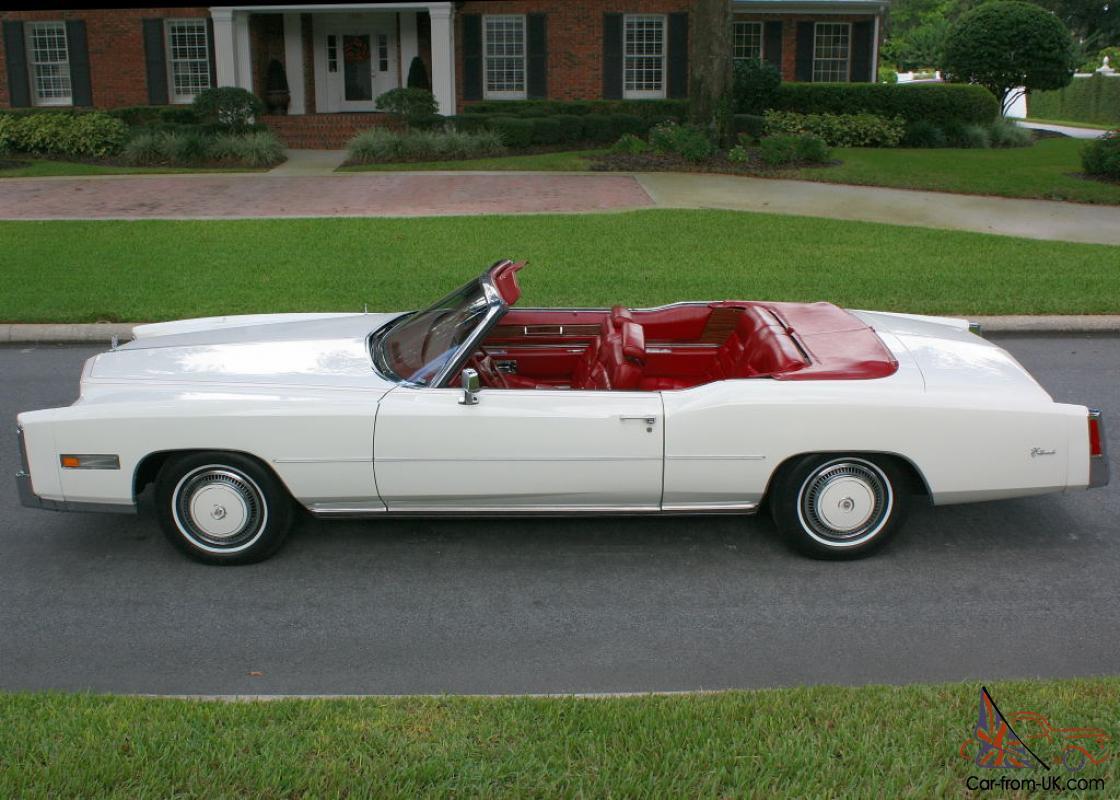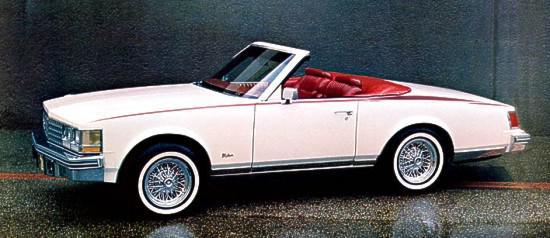The first image is the image on the left, the second image is the image on the right. For the images displayed, is the sentence "In one image exactly one convertible car is on the grass." factually correct? Answer yes or no. No. The first image is the image on the left, the second image is the image on the right. Examine the images to the left and right. Is the description "1 car has it's convertible top up." accurate? Answer yes or no. No. 